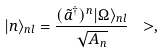<formula> <loc_0><loc_0><loc_500><loc_500>| n \rangle _ { n l } = \frac { ( \tilde { a } ^ { \dagger } ) ^ { n } | \Omega \rangle _ { n l } } { \sqrt { A _ { n } } } \ > ,</formula> 